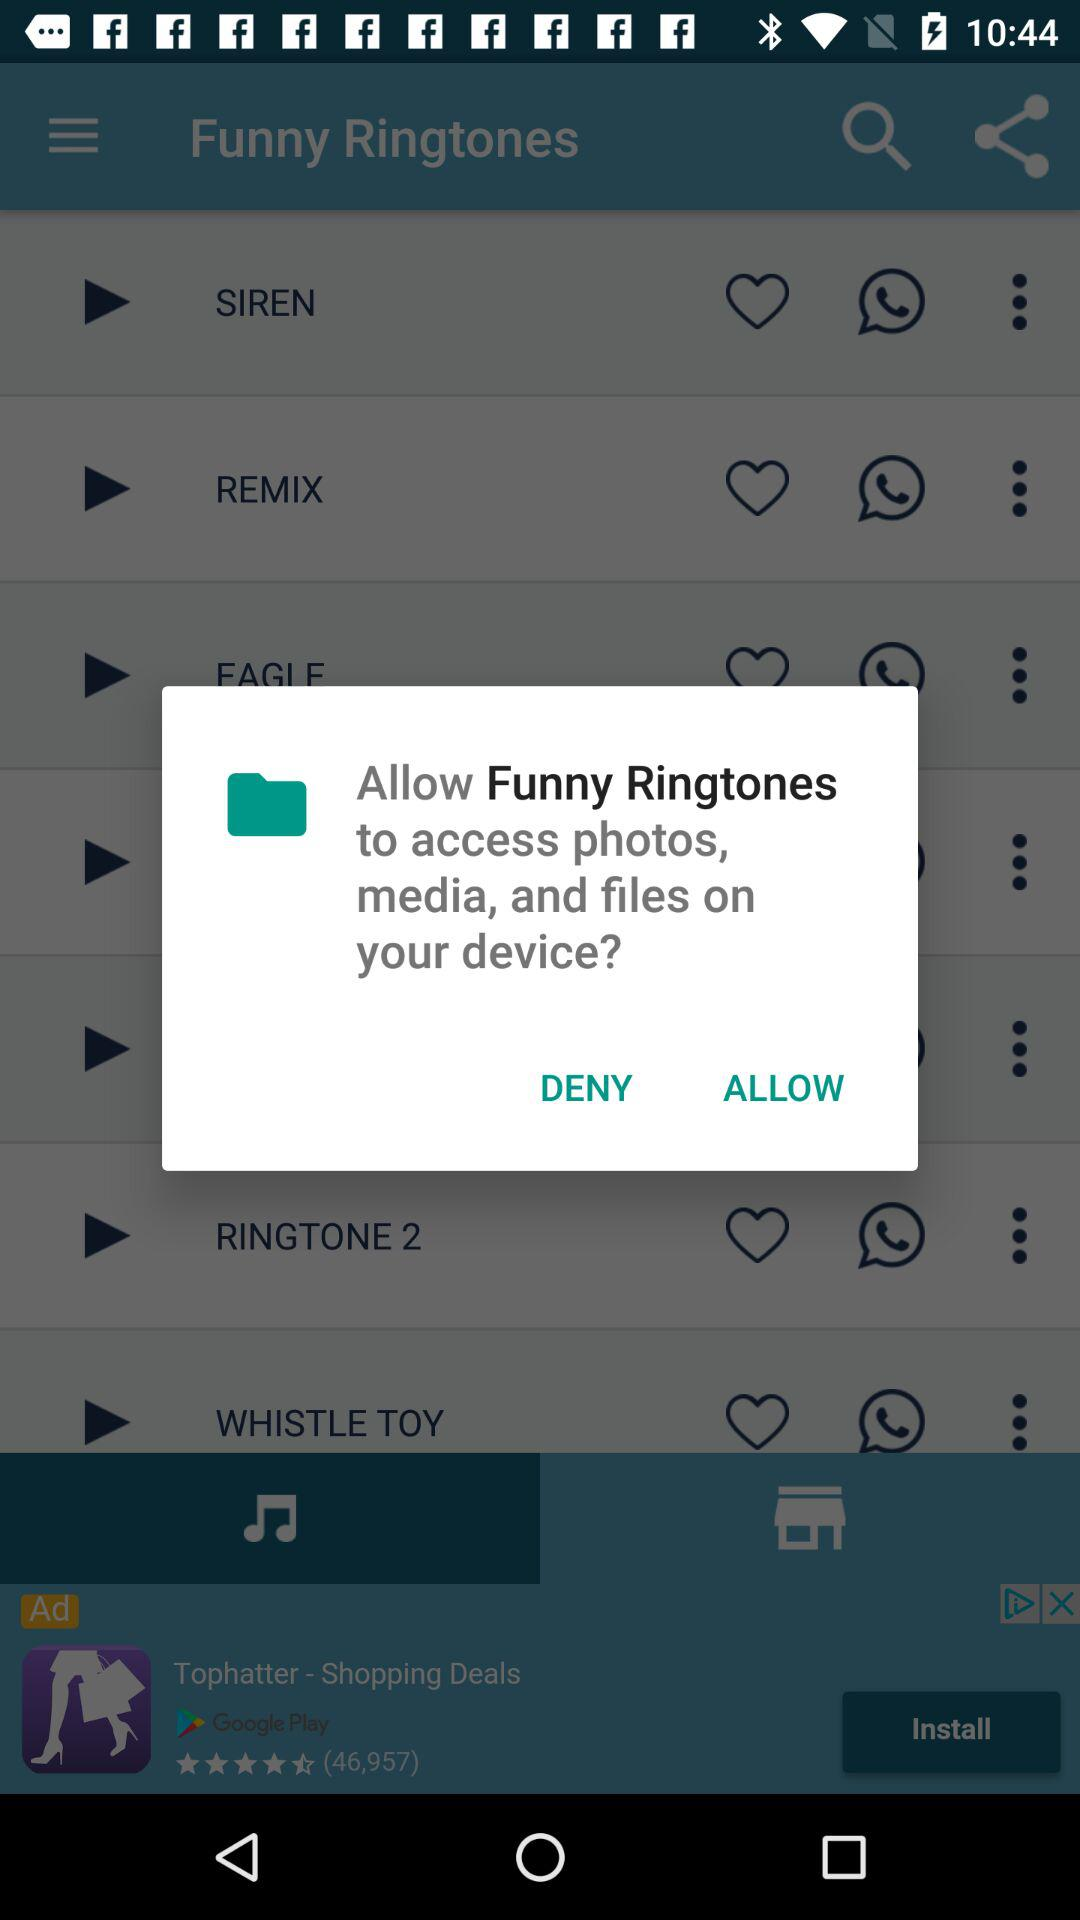What application is asking for permission? The application that is asking for permission is "Funny Ringtones". 